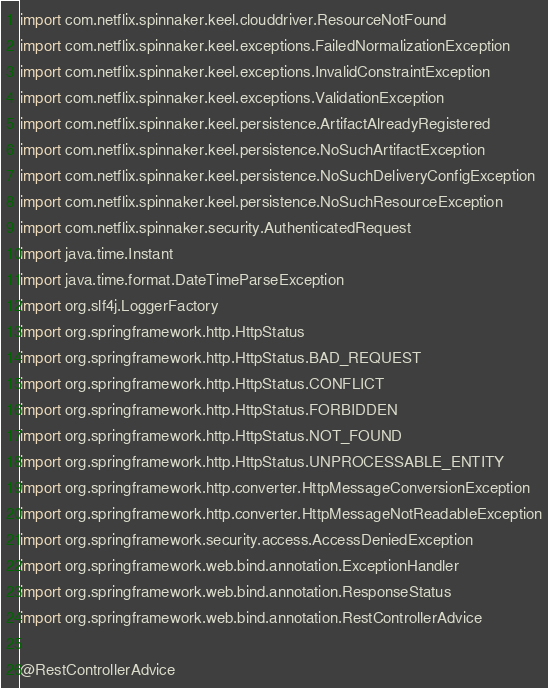Convert code to text. <code><loc_0><loc_0><loc_500><loc_500><_Kotlin_>import com.netflix.spinnaker.keel.clouddriver.ResourceNotFound
import com.netflix.spinnaker.keel.exceptions.FailedNormalizationException
import com.netflix.spinnaker.keel.exceptions.InvalidConstraintException
import com.netflix.spinnaker.keel.exceptions.ValidationException
import com.netflix.spinnaker.keel.persistence.ArtifactAlreadyRegistered
import com.netflix.spinnaker.keel.persistence.NoSuchArtifactException
import com.netflix.spinnaker.keel.persistence.NoSuchDeliveryConfigException
import com.netflix.spinnaker.keel.persistence.NoSuchResourceException
import com.netflix.spinnaker.security.AuthenticatedRequest
import java.time.Instant
import java.time.format.DateTimeParseException
import org.slf4j.LoggerFactory
import org.springframework.http.HttpStatus
import org.springframework.http.HttpStatus.BAD_REQUEST
import org.springframework.http.HttpStatus.CONFLICT
import org.springframework.http.HttpStatus.FORBIDDEN
import org.springframework.http.HttpStatus.NOT_FOUND
import org.springframework.http.HttpStatus.UNPROCESSABLE_ENTITY
import org.springframework.http.converter.HttpMessageConversionException
import org.springframework.http.converter.HttpMessageNotReadableException
import org.springframework.security.access.AccessDeniedException
import org.springframework.web.bind.annotation.ExceptionHandler
import org.springframework.web.bind.annotation.ResponseStatus
import org.springframework.web.bind.annotation.RestControllerAdvice

@RestControllerAdvice</code> 